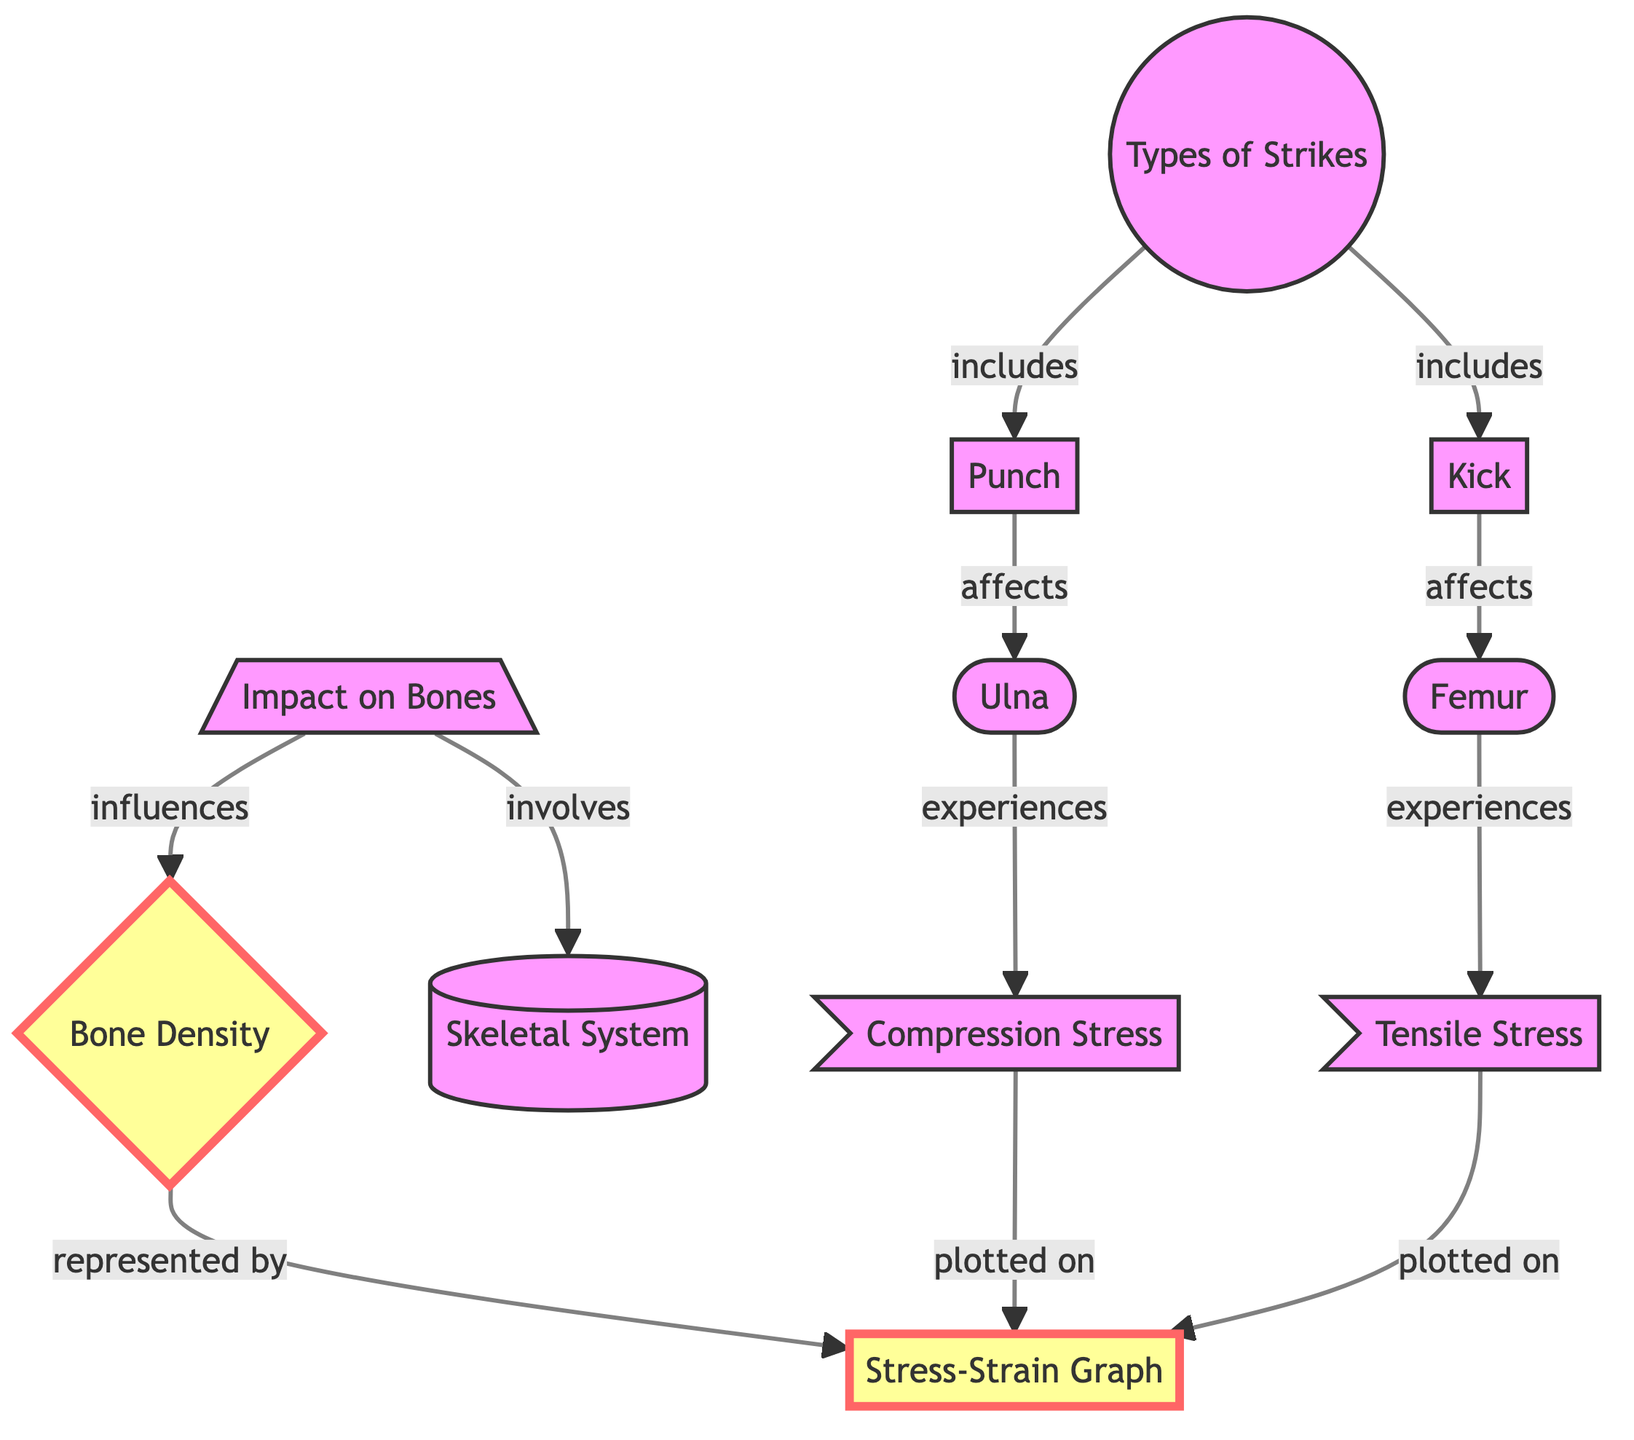What are the types of strikes included in this diagram? The diagram specifically lists two types of strikes under the "Types of Strikes" node: "Punch" and "Kick". This information can be directly referenced from the connections shown in the flowchart.
Answer: Punch, Kick Which bone is affected by the punch? Looking at the connections in the diagram, the "Punch" node is linked to the "Ulna", indicating that the ulna is the bone affected by punch strikes.
Answer: Ulna Which bone experiences tensile stress? The diagram indicates that the "Femur" experiences tensile stress as per the relationship drawn between "Kick" and "Femur", which is also linked to "Tensile Stress".
Answer: Femur How does the impact on bones influence bone density? The diagram shows that the "Impact on Bones" node is involved in influencing "Bone Density", indicating a direct relationship between the two elements, which clearly highlights how one affects the other.
Answer: Influences What is represented by the stress-strain graph? The diagram connects "Bone Density" to the "Stress-Strain Graph", indicating that bone density is visually represented in the stress-strain graph. This is a straightforward identification based on the relationships illustrated.
Answer: Bone Density How many striking types are shown in the diagram? The two types of strikes "Punch" and "Kick" indicate a total of two types of striking techniques presented in the diagram under the "Types of Strikes" node.
Answer: Two What type of stress is plotted on the stress-strain graph for the ulna? The diagram states that "Compression Stress" is experienced by the ulna and that this stress is also plotted on the "Stress-Strain Graph", clearly linking the two concepts.
Answer: Compression Stress What influences bone density according to the diagram? The diagram identifies that "Impact on Bones" influences "Bone Density", showing a direct flow of influence from one concept to the other in the biomedical context.
Answer: Impact on Bones What does the skeletal system involve? According to the diagram, the "Impact on Bones" node involves the "Skeletal System", indicating the relationship where impacts contribute to or interact with the skeletal structure.
Answer: Skeletal System 